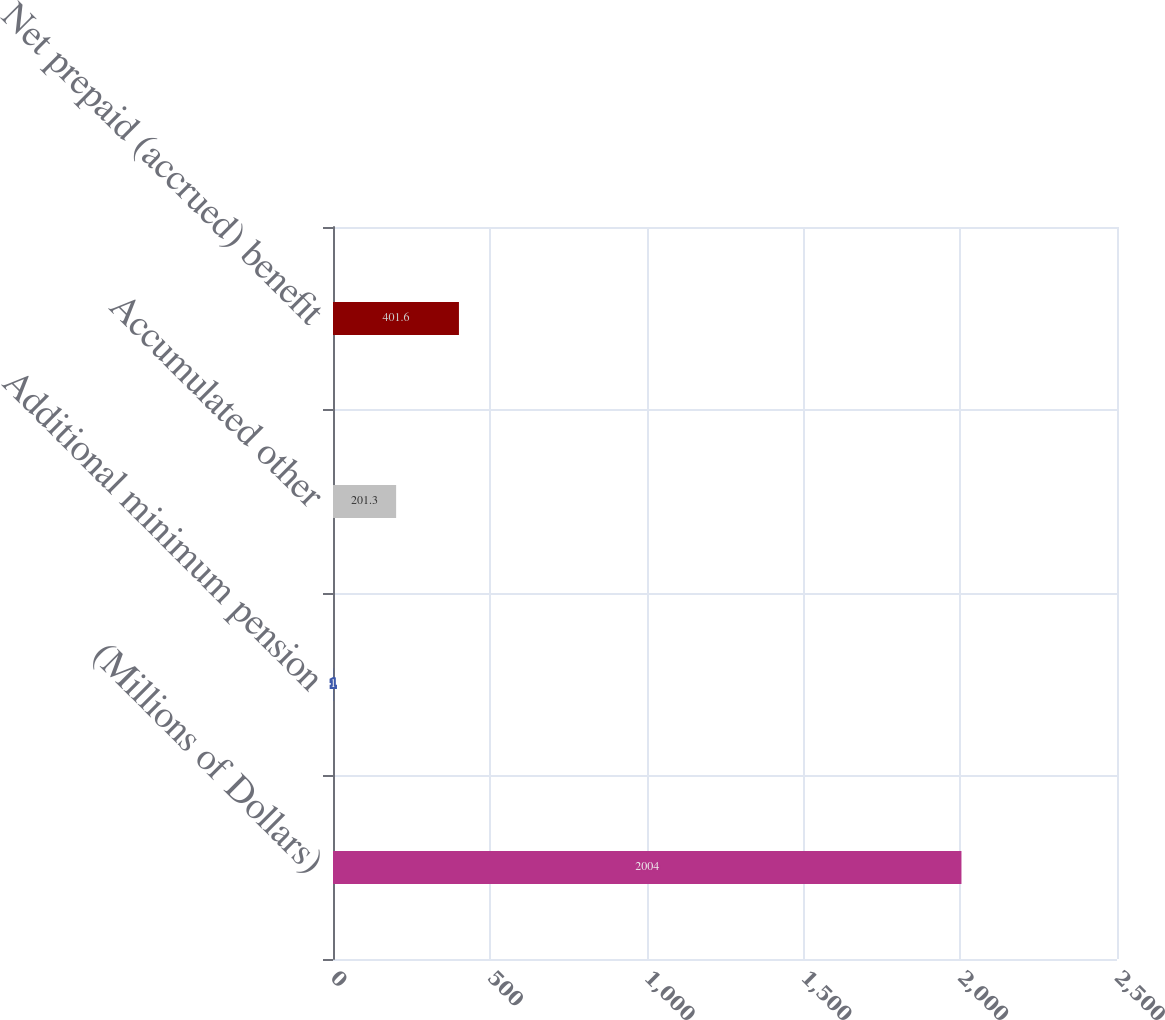Convert chart. <chart><loc_0><loc_0><loc_500><loc_500><bar_chart><fcel>(Millions of Dollars)<fcel>Additional minimum pension<fcel>Accumulated other<fcel>Net prepaid (accrued) benefit<nl><fcel>2004<fcel>1<fcel>201.3<fcel>401.6<nl></chart> 